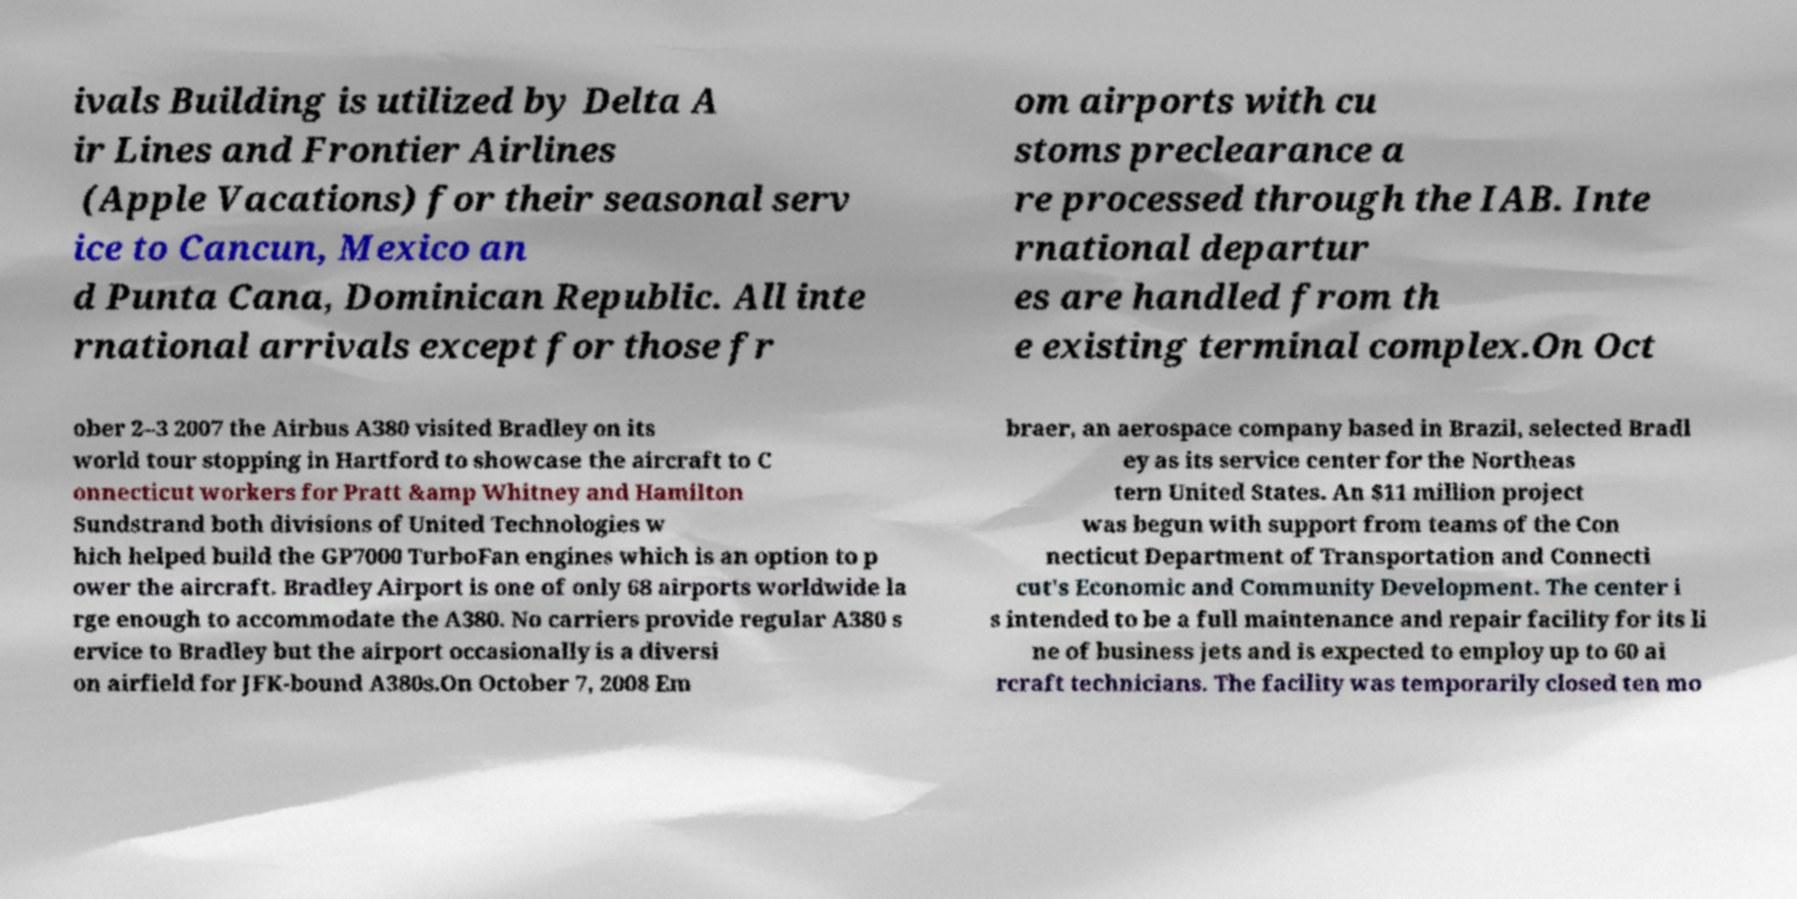For documentation purposes, I need the text within this image transcribed. Could you provide that? ivals Building is utilized by Delta A ir Lines and Frontier Airlines (Apple Vacations) for their seasonal serv ice to Cancun, Mexico an d Punta Cana, Dominican Republic. All inte rnational arrivals except for those fr om airports with cu stoms preclearance a re processed through the IAB. Inte rnational departur es are handled from th e existing terminal complex.On Oct ober 2–3 2007 the Airbus A380 visited Bradley on its world tour stopping in Hartford to showcase the aircraft to C onnecticut workers for Pratt &amp Whitney and Hamilton Sundstrand both divisions of United Technologies w hich helped build the GP7000 TurboFan engines which is an option to p ower the aircraft. Bradley Airport is one of only 68 airports worldwide la rge enough to accommodate the A380. No carriers provide regular A380 s ervice to Bradley but the airport occasionally is a diversi on airfield for JFK-bound A380s.On October 7, 2008 Em braer, an aerospace company based in Brazil, selected Bradl ey as its service center for the Northeas tern United States. An $11 million project was begun with support from teams of the Con necticut Department of Transportation and Connecti cut's Economic and Community Development. The center i s intended to be a full maintenance and repair facility for its li ne of business jets and is expected to employ up to 60 ai rcraft technicians. The facility was temporarily closed ten mo 